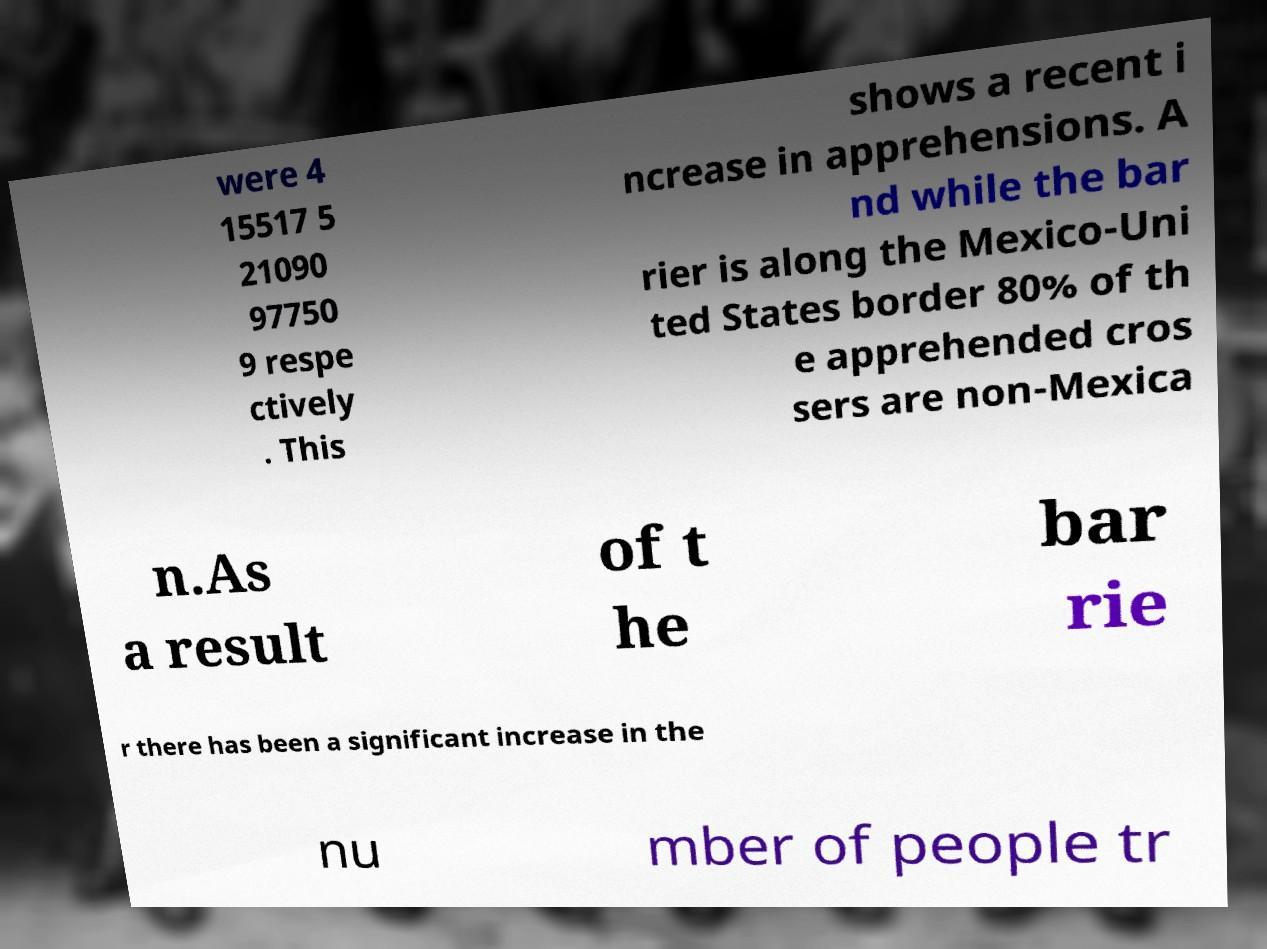Can you read and provide the text displayed in the image?This photo seems to have some interesting text. Can you extract and type it out for me? were 4 15517 5 21090 97750 9 respe ctively . This shows a recent i ncrease in apprehensions. A nd while the bar rier is along the Mexico-Uni ted States border 80% of th e apprehended cros sers are non-Mexica n.As a result of t he bar rie r there has been a significant increase in the nu mber of people tr 